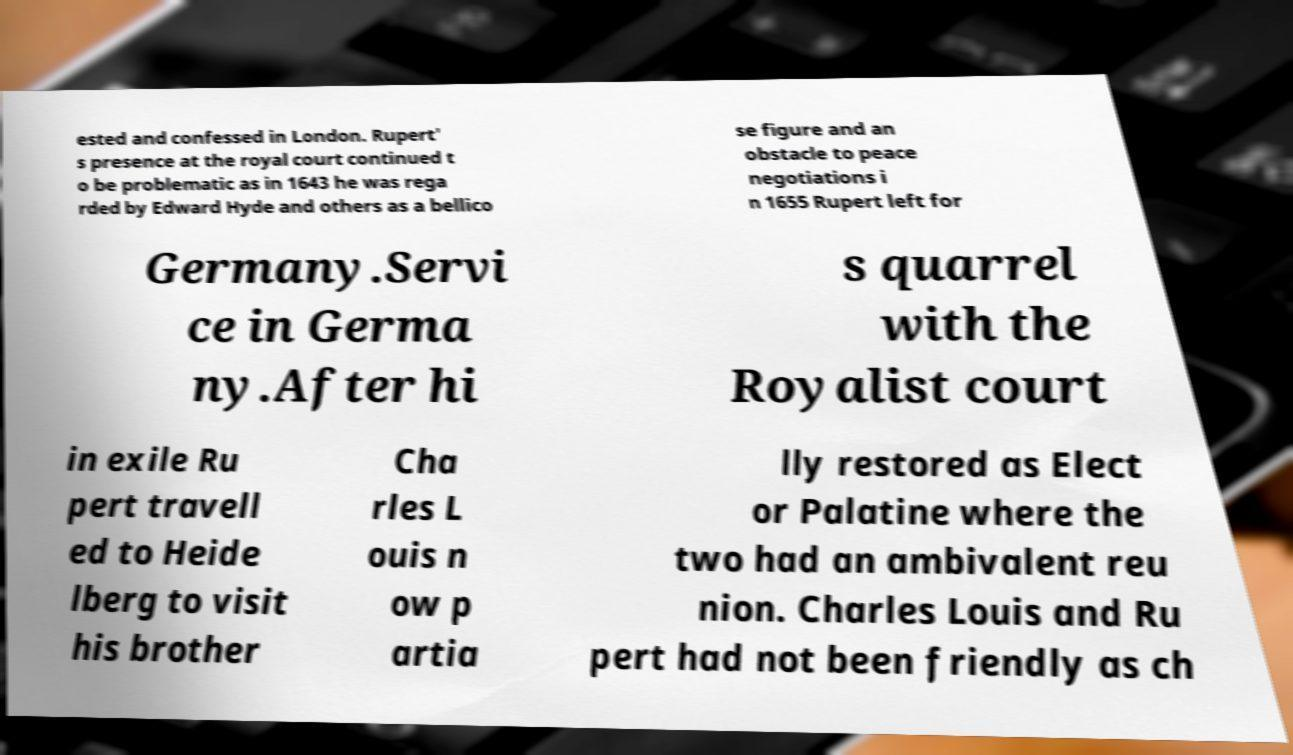Could you assist in decoding the text presented in this image and type it out clearly? ested and confessed in London. Rupert' s presence at the royal court continued t o be problematic as in 1643 he was rega rded by Edward Hyde and others as a bellico se figure and an obstacle to peace negotiations i n 1655 Rupert left for Germany.Servi ce in Germa ny.After hi s quarrel with the Royalist court in exile Ru pert travell ed to Heide lberg to visit his brother Cha rles L ouis n ow p artia lly restored as Elect or Palatine where the two had an ambivalent reu nion. Charles Louis and Ru pert had not been friendly as ch 